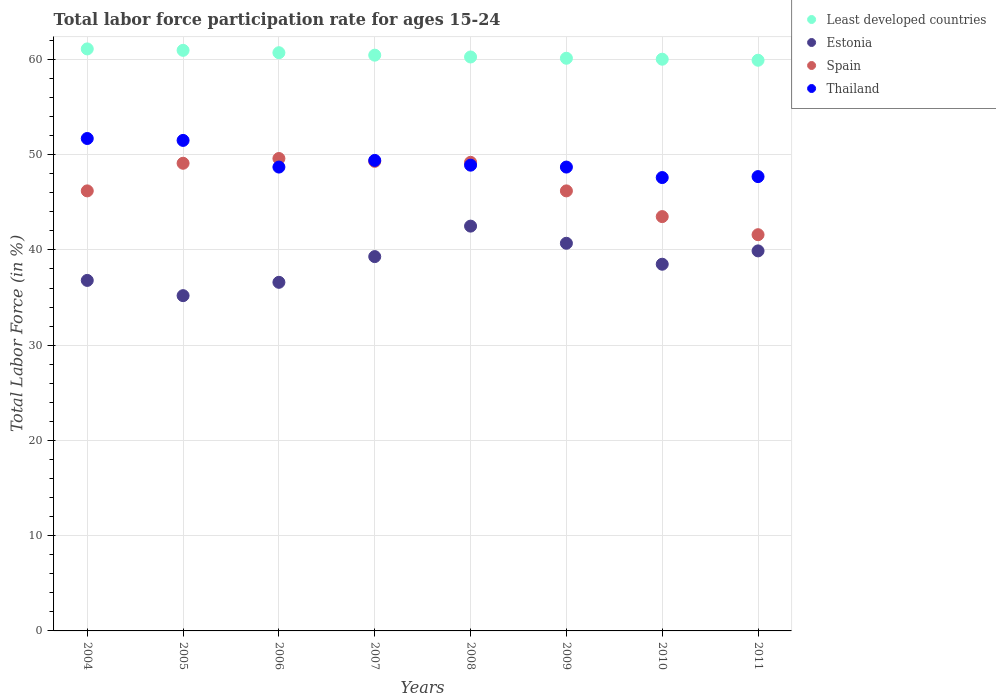Is the number of dotlines equal to the number of legend labels?
Ensure brevity in your answer.  Yes. What is the labor force participation rate in Estonia in 2004?
Provide a short and direct response. 36.8. Across all years, what is the maximum labor force participation rate in Thailand?
Provide a short and direct response. 51.7. Across all years, what is the minimum labor force participation rate in Least developed countries?
Provide a succinct answer. 59.92. What is the total labor force participation rate in Least developed countries in the graph?
Keep it short and to the point. 483.54. What is the difference between the labor force participation rate in Least developed countries in 2009 and that in 2011?
Your answer should be compact. 0.21. What is the difference between the labor force participation rate in Thailand in 2004 and the labor force participation rate in Estonia in 2010?
Keep it short and to the point. 13.2. What is the average labor force participation rate in Spain per year?
Provide a short and direct response. 46.84. In the year 2008, what is the difference between the labor force participation rate in Least developed countries and labor force participation rate in Spain?
Keep it short and to the point. 11.06. In how many years, is the labor force participation rate in Spain greater than 46 %?
Offer a very short reply. 6. What is the ratio of the labor force participation rate in Least developed countries in 2005 to that in 2009?
Give a very brief answer. 1.01. Is the labor force participation rate in Thailand in 2008 less than that in 2009?
Ensure brevity in your answer.  No. Is the difference between the labor force participation rate in Least developed countries in 2006 and 2007 greater than the difference between the labor force participation rate in Spain in 2006 and 2007?
Provide a succinct answer. No. What is the difference between the highest and the second highest labor force participation rate in Least developed countries?
Your response must be concise. 0.15. Is the sum of the labor force participation rate in Estonia in 2004 and 2006 greater than the maximum labor force participation rate in Spain across all years?
Your response must be concise. Yes. Is the labor force participation rate in Thailand strictly greater than the labor force participation rate in Estonia over the years?
Your answer should be very brief. Yes. How many years are there in the graph?
Your answer should be compact. 8. What is the difference between two consecutive major ticks on the Y-axis?
Keep it short and to the point. 10. Are the values on the major ticks of Y-axis written in scientific E-notation?
Your answer should be compact. No. Where does the legend appear in the graph?
Ensure brevity in your answer.  Top right. What is the title of the graph?
Provide a succinct answer. Total labor force participation rate for ages 15-24. What is the label or title of the Y-axis?
Your answer should be very brief. Total Labor Force (in %). What is the Total Labor Force (in %) in Least developed countries in 2004?
Your answer should be compact. 61.11. What is the Total Labor Force (in %) in Estonia in 2004?
Ensure brevity in your answer.  36.8. What is the Total Labor Force (in %) in Spain in 2004?
Keep it short and to the point. 46.2. What is the Total Labor Force (in %) of Thailand in 2004?
Your answer should be compact. 51.7. What is the Total Labor Force (in %) in Least developed countries in 2005?
Give a very brief answer. 60.96. What is the Total Labor Force (in %) in Estonia in 2005?
Provide a succinct answer. 35.2. What is the Total Labor Force (in %) of Spain in 2005?
Provide a succinct answer. 49.1. What is the Total Labor Force (in %) of Thailand in 2005?
Offer a very short reply. 51.5. What is the Total Labor Force (in %) in Least developed countries in 2006?
Your response must be concise. 60.71. What is the Total Labor Force (in %) in Estonia in 2006?
Provide a succinct answer. 36.6. What is the Total Labor Force (in %) of Spain in 2006?
Ensure brevity in your answer.  49.6. What is the Total Labor Force (in %) of Thailand in 2006?
Ensure brevity in your answer.  48.7. What is the Total Labor Force (in %) of Least developed countries in 2007?
Keep it short and to the point. 60.45. What is the Total Labor Force (in %) in Estonia in 2007?
Give a very brief answer. 39.3. What is the Total Labor Force (in %) in Spain in 2007?
Give a very brief answer. 49.3. What is the Total Labor Force (in %) of Thailand in 2007?
Give a very brief answer. 49.4. What is the Total Labor Force (in %) in Least developed countries in 2008?
Make the answer very short. 60.26. What is the Total Labor Force (in %) of Estonia in 2008?
Your response must be concise. 42.5. What is the Total Labor Force (in %) in Spain in 2008?
Keep it short and to the point. 49.2. What is the Total Labor Force (in %) of Thailand in 2008?
Your response must be concise. 48.9. What is the Total Labor Force (in %) in Least developed countries in 2009?
Ensure brevity in your answer.  60.13. What is the Total Labor Force (in %) of Estonia in 2009?
Give a very brief answer. 40.7. What is the Total Labor Force (in %) in Spain in 2009?
Provide a succinct answer. 46.2. What is the Total Labor Force (in %) in Thailand in 2009?
Your response must be concise. 48.7. What is the Total Labor Force (in %) in Least developed countries in 2010?
Offer a terse response. 60.02. What is the Total Labor Force (in %) in Estonia in 2010?
Offer a very short reply. 38.5. What is the Total Labor Force (in %) of Spain in 2010?
Provide a short and direct response. 43.5. What is the Total Labor Force (in %) in Thailand in 2010?
Ensure brevity in your answer.  47.6. What is the Total Labor Force (in %) of Least developed countries in 2011?
Provide a short and direct response. 59.92. What is the Total Labor Force (in %) in Estonia in 2011?
Make the answer very short. 39.9. What is the Total Labor Force (in %) of Spain in 2011?
Your answer should be very brief. 41.6. What is the Total Labor Force (in %) of Thailand in 2011?
Offer a terse response. 47.7. Across all years, what is the maximum Total Labor Force (in %) of Least developed countries?
Ensure brevity in your answer.  61.11. Across all years, what is the maximum Total Labor Force (in %) of Estonia?
Your response must be concise. 42.5. Across all years, what is the maximum Total Labor Force (in %) in Spain?
Make the answer very short. 49.6. Across all years, what is the maximum Total Labor Force (in %) of Thailand?
Offer a terse response. 51.7. Across all years, what is the minimum Total Labor Force (in %) of Least developed countries?
Ensure brevity in your answer.  59.92. Across all years, what is the minimum Total Labor Force (in %) in Estonia?
Provide a short and direct response. 35.2. Across all years, what is the minimum Total Labor Force (in %) of Spain?
Offer a terse response. 41.6. Across all years, what is the minimum Total Labor Force (in %) in Thailand?
Your response must be concise. 47.6. What is the total Total Labor Force (in %) of Least developed countries in the graph?
Your answer should be compact. 483.54. What is the total Total Labor Force (in %) in Estonia in the graph?
Your answer should be very brief. 309.5. What is the total Total Labor Force (in %) in Spain in the graph?
Provide a succinct answer. 374.7. What is the total Total Labor Force (in %) in Thailand in the graph?
Ensure brevity in your answer.  394.2. What is the difference between the Total Labor Force (in %) of Least developed countries in 2004 and that in 2005?
Provide a succinct answer. 0.15. What is the difference between the Total Labor Force (in %) of Least developed countries in 2004 and that in 2006?
Give a very brief answer. 0.4. What is the difference between the Total Labor Force (in %) in Least developed countries in 2004 and that in 2007?
Your answer should be very brief. 0.66. What is the difference between the Total Labor Force (in %) in Spain in 2004 and that in 2007?
Your answer should be very brief. -3.1. What is the difference between the Total Labor Force (in %) in Thailand in 2004 and that in 2007?
Offer a terse response. 2.3. What is the difference between the Total Labor Force (in %) of Least developed countries in 2004 and that in 2008?
Provide a short and direct response. 0.85. What is the difference between the Total Labor Force (in %) of Least developed countries in 2004 and that in 2009?
Your answer should be very brief. 0.98. What is the difference between the Total Labor Force (in %) in Estonia in 2004 and that in 2009?
Provide a succinct answer. -3.9. What is the difference between the Total Labor Force (in %) of Thailand in 2004 and that in 2009?
Offer a very short reply. 3. What is the difference between the Total Labor Force (in %) of Least developed countries in 2004 and that in 2010?
Offer a terse response. 1.08. What is the difference between the Total Labor Force (in %) in Estonia in 2004 and that in 2010?
Give a very brief answer. -1.7. What is the difference between the Total Labor Force (in %) of Spain in 2004 and that in 2010?
Offer a terse response. 2.7. What is the difference between the Total Labor Force (in %) in Thailand in 2004 and that in 2010?
Your answer should be compact. 4.1. What is the difference between the Total Labor Force (in %) of Least developed countries in 2004 and that in 2011?
Give a very brief answer. 1.19. What is the difference between the Total Labor Force (in %) of Estonia in 2004 and that in 2011?
Offer a terse response. -3.1. What is the difference between the Total Labor Force (in %) in Thailand in 2004 and that in 2011?
Provide a short and direct response. 4. What is the difference between the Total Labor Force (in %) in Least developed countries in 2005 and that in 2006?
Offer a terse response. 0.25. What is the difference between the Total Labor Force (in %) in Spain in 2005 and that in 2006?
Your response must be concise. -0.5. What is the difference between the Total Labor Force (in %) of Least developed countries in 2005 and that in 2007?
Offer a terse response. 0.51. What is the difference between the Total Labor Force (in %) in Estonia in 2005 and that in 2007?
Make the answer very short. -4.1. What is the difference between the Total Labor Force (in %) in Least developed countries in 2005 and that in 2008?
Your answer should be compact. 0.7. What is the difference between the Total Labor Force (in %) in Thailand in 2005 and that in 2008?
Make the answer very short. 2.6. What is the difference between the Total Labor Force (in %) of Least developed countries in 2005 and that in 2009?
Your answer should be very brief. 0.83. What is the difference between the Total Labor Force (in %) of Estonia in 2005 and that in 2009?
Provide a short and direct response. -5.5. What is the difference between the Total Labor Force (in %) in Spain in 2005 and that in 2009?
Your answer should be very brief. 2.9. What is the difference between the Total Labor Force (in %) of Least developed countries in 2005 and that in 2010?
Offer a very short reply. 0.93. What is the difference between the Total Labor Force (in %) in Spain in 2005 and that in 2010?
Provide a short and direct response. 5.6. What is the difference between the Total Labor Force (in %) in Least developed countries in 2005 and that in 2011?
Provide a short and direct response. 1.04. What is the difference between the Total Labor Force (in %) of Estonia in 2005 and that in 2011?
Offer a terse response. -4.7. What is the difference between the Total Labor Force (in %) of Spain in 2005 and that in 2011?
Keep it short and to the point. 7.5. What is the difference between the Total Labor Force (in %) in Thailand in 2005 and that in 2011?
Provide a short and direct response. 3.8. What is the difference between the Total Labor Force (in %) of Least developed countries in 2006 and that in 2007?
Provide a succinct answer. 0.26. What is the difference between the Total Labor Force (in %) of Spain in 2006 and that in 2007?
Offer a very short reply. 0.3. What is the difference between the Total Labor Force (in %) of Thailand in 2006 and that in 2007?
Your answer should be very brief. -0.7. What is the difference between the Total Labor Force (in %) of Least developed countries in 2006 and that in 2008?
Ensure brevity in your answer.  0.45. What is the difference between the Total Labor Force (in %) in Least developed countries in 2006 and that in 2009?
Your answer should be compact. 0.58. What is the difference between the Total Labor Force (in %) in Spain in 2006 and that in 2009?
Offer a very short reply. 3.4. What is the difference between the Total Labor Force (in %) in Least developed countries in 2006 and that in 2010?
Provide a succinct answer. 0.68. What is the difference between the Total Labor Force (in %) of Estonia in 2006 and that in 2010?
Ensure brevity in your answer.  -1.9. What is the difference between the Total Labor Force (in %) of Spain in 2006 and that in 2010?
Ensure brevity in your answer.  6.1. What is the difference between the Total Labor Force (in %) in Least developed countries in 2006 and that in 2011?
Provide a succinct answer. 0.79. What is the difference between the Total Labor Force (in %) in Estonia in 2006 and that in 2011?
Keep it short and to the point. -3.3. What is the difference between the Total Labor Force (in %) of Thailand in 2006 and that in 2011?
Provide a short and direct response. 1. What is the difference between the Total Labor Force (in %) of Least developed countries in 2007 and that in 2008?
Provide a short and direct response. 0.19. What is the difference between the Total Labor Force (in %) of Least developed countries in 2007 and that in 2009?
Make the answer very short. 0.32. What is the difference between the Total Labor Force (in %) of Estonia in 2007 and that in 2009?
Offer a very short reply. -1.4. What is the difference between the Total Labor Force (in %) of Spain in 2007 and that in 2009?
Provide a succinct answer. 3.1. What is the difference between the Total Labor Force (in %) of Thailand in 2007 and that in 2009?
Provide a short and direct response. 0.7. What is the difference between the Total Labor Force (in %) in Least developed countries in 2007 and that in 2010?
Keep it short and to the point. 0.42. What is the difference between the Total Labor Force (in %) of Estonia in 2007 and that in 2010?
Give a very brief answer. 0.8. What is the difference between the Total Labor Force (in %) of Spain in 2007 and that in 2010?
Make the answer very short. 5.8. What is the difference between the Total Labor Force (in %) in Thailand in 2007 and that in 2010?
Keep it short and to the point. 1.8. What is the difference between the Total Labor Force (in %) in Least developed countries in 2007 and that in 2011?
Keep it short and to the point. 0.53. What is the difference between the Total Labor Force (in %) of Spain in 2007 and that in 2011?
Keep it short and to the point. 7.7. What is the difference between the Total Labor Force (in %) of Least developed countries in 2008 and that in 2009?
Offer a very short reply. 0.13. What is the difference between the Total Labor Force (in %) in Least developed countries in 2008 and that in 2010?
Your answer should be compact. 0.23. What is the difference between the Total Labor Force (in %) in Thailand in 2008 and that in 2010?
Offer a very short reply. 1.3. What is the difference between the Total Labor Force (in %) of Least developed countries in 2008 and that in 2011?
Provide a succinct answer. 0.34. What is the difference between the Total Labor Force (in %) of Estonia in 2008 and that in 2011?
Give a very brief answer. 2.6. What is the difference between the Total Labor Force (in %) of Spain in 2008 and that in 2011?
Make the answer very short. 7.6. What is the difference between the Total Labor Force (in %) in Thailand in 2008 and that in 2011?
Give a very brief answer. 1.2. What is the difference between the Total Labor Force (in %) in Least developed countries in 2009 and that in 2010?
Offer a terse response. 0.1. What is the difference between the Total Labor Force (in %) in Estonia in 2009 and that in 2010?
Your response must be concise. 2.2. What is the difference between the Total Labor Force (in %) of Thailand in 2009 and that in 2010?
Provide a short and direct response. 1.1. What is the difference between the Total Labor Force (in %) in Least developed countries in 2009 and that in 2011?
Offer a very short reply. 0.21. What is the difference between the Total Labor Force (in %) in Estonia in 2009 and that in 2011?
Offer a terse response. 0.8. What is the difference between the Total Labor Force (in %) of Least developed countries in 2010 and that in 2011?
Your response must be concise. 0.11. What is the difference between the Total Labor Force (in %) of Estonia in 2010 and that in 2011?
Offer a very short reply. -1.4. What is the difference between the Total Labor Force (in %) in Thailand in 2010 and that in 2011?
Make the answer very short. -0.1. What is the difference between the Total Labor Force (in %) in Least developed countries in 2004 and the Total Labor Force (in %) in Estonia in 2005?
Keep it short and to the point. 25.91. What is the difference between the Total Labor Force (in %) of Least developed countries in 2004 and the Total Labor Force (in %) of Spain in 2005?
Keep it short and to the point. 12.01. What is the difference between the Total Labor Force (in %) in Least developed countries in 2004 and the Total Labor Force (in %) in Thailand in 2005?
Provide a succinct answer. 9.61. What is the difference between the Total Labor Force (in %) of Estonia in 2004 and the Total Labor Force (in %) of Thailand in 2005?
Ensure brevity in your answer.  -14.7. What is the difference between the Total Labor Force (in %) in Spain in 2004 and the Total Labor Force (in %) in Thailand in 2005?
Keep it short and to the point. -5.3. What is the difference between the Total Labor Force (in %) in Least developed countries in 2004 and the Total Labor Force (in %) in Estonia in 2006?
Offer a very short reply. 24.51. What is the difference between the Total Labor Force (in %) in Least developed countries in 2004 and the Total Labor Force (in %) in Spain in 2006?
Provide a short and direct response. 11.51. What is the difference between the Total Labor Force (in %) in Least developed countries in 2004 and the Total Labor Force (in %) in Thailand in 2006?
Ensure brevity in your answer.  12.41. What is the difference between the Total Labor Force (in %) of Estonia in 2004 and the Total Labor Force (in %) of Spain in 2006?
Give a very brief answer. -12.8. What is the difference between the Total Labor Force (in %) in Estonia in 2004 and the Total Labor Force (in %) in Thailand in 2006?
Offer a very short reply. -11.9. What is the difference between the Total Labor Force (in %) of Spain in 2004 and the Total Labor Force (in %) of Thailand in 2006?
Your answer should be very brief. -2.5. What is the difference between the Total Labor Force (in %) of Least developed countries in 2004 and the Total Labor Force (in %) of Estonia in 2007?
Your response must be concise. 21.81. What is the difference between the Total Labor Force (in %) in Least developed countries in 2004 and the Total Labor Force (in %) in Spain in 2007?
Give a very brief answer. 11.81. What is the difference between the Total Labor Force (in %) of Least developed countries in 2004 and the Total Labor Force (in %) of Thailand in 2007?
Provide a succinct answer. 11.71. What is the difference between the Total Labor Force (in %) in Estonia in 2004 and the Total Labor Force (in %) in Spain in 2007?
Give a very brief answer. -12.5. What is the difference between the Total Labor Force (in %) in Spain in 2004 and the Total Labor Force (in %) in Thailand in 2007?
Keep it short and to the point. -3.2. What is the difference between the Total Labor Force (in %) of Least developed countries in 2004 and the Total Labor Force (in %) of Estonia in 2008?
Offer a terse response. 18.61. What is the difference between the Total Labor Force (in %) of Least developed countries in 2004 and the Total Labor Force (in %) of Spain in 2008?
Offer a terse response. 11.91. What is the difference between the Total Labor Force (in %) of Least developed countries in 2004 and the Total Labor Force (in %) of Thailand in 2008?
Your answer should be compact. 12.21. What is the difference between the Total Labor Force (in %) of Estonia in 2004 and the Total Labor Force (in %) of Thailand in 2008?
Offer a very short reply. -12.1. What is the difference between the Total Labor Force (in %) of Spain in 2004 and the Total Labor Force (in %) of Thailand in 2008?
Give a very brief answer. -2.7. What is the difference between the Total Labor Force (in %) in Least developed countries in 2004 and the Total Labor Force (in %) in Estonia in 2009?
Your answer should be compact. 20.41. What is the difference between the Total Labor Force (in %) in Least developed countries in 2004 and the Total Labor Force (in %) in Spain in 2009?
Your answer should be very brief. 14.91. What is the difference between the Total Labor Force (in %) of Least developed countries in 2004 and the Total Labor Force (in %) of Thailand in 2009?
Provide a succinct answer. 12.41. What is the difference between the Total Labor Force (in %) in Estonia in 2004 and the Total Labor Force (in %) in Thailand in 2009?
Make the answer very short. -11.9. What is the difference between the Total Labor Force (in %) in Spain in 2004 and the Total Labor Force (in %) in Thailand in 2009?
Provide a short and direct response. -2.5. What is the difference between the Total Labor Force (in %) in Least developed countries in 2004 and the Total Labor Force (in %) in Estonia in 2010?
Make the answer very short. 22.61. What is the difference between the Total Labor Force (in %) of Least developed countries in 2004 and the Total Labor Force (in %) of Spain in 2010?
Offer a terse response. 17.61. What is the difference between the Total Labor Force (in %) in Least developed countries in 2004 and the Total Labor Force (in %) in Thailand in 2010?
Make the answer very short. 13.51. What is the difference between the Total Labor Force (in %) in Estonia in 2004 and the Total Labor Force (in %) in Thailand in 2010?
Keep it short and to the point. -10.8. What is the difference between the Total Labor Force (in %) in Least developed countries in 2004 and the Total Labor Force (in %) in Estonia in 2011?
Provide a succinct answer. 21.21. What is the difference between the Total Labor Force (in %) of Least developed countries in 2004 and the Total Labor Force (in %) of Spain in 2011?
Offer a very short reply. 19.51. What is the difference between the Total Labor Force (in %) in Least developed countries in 2004 and the Total Labor Force (in %) in Thailand in 2011?
Make the answer very short. 13.41. What is the difference between the Total Labor Force (in %) in Estonia in 2004 and the Total Labor Force (in %) in Spain in 2011?
Ensure brevity in your answer.  -4.8. What is the difference between the Total Labor Force (in %) of Estonia in 2004 and the Total Labor Force (in %) of Thailand in 2011?
Provide a short and direct response. -10.9. What is the difference between the Total Labor Force (in %) in Least developed countries in 2005 and the Total Labor Force (in %) in Estonia in 2006?
Ensure brevity in your answer.  24.36. What is the difference between the Total Labor Force (in %) of Least developed countries in 2005 and the Total Labor Force (in %) of Spain in 2006?
Your answer should be very brief. 11.36. What is the difference between the Total Labor Force (in %) of Least developed countries in 2005 and the Total Labor Force (in %) of Thailand in 2006?
Offer a very short reply. 12.26. What is the difference between the Total Labor Force (in %) in Estonia in 2005 and the Total Labor Force (in %) in Spain in 2006?
Keep it short and to the point. -14.4. What is the difference between the Total Labor Force (in %) of Estonia in 2005 and the Total Labor Force (in %) of Thailand in 2006?
Your answer should be compact. -13.5. What is the difference between the Total Labor Force (in %) in Spain in 2005 and the Total Labor Force (in %) in Thailand in 2006?
Make the answer very short. 0.4. What is the difference between the Total Labor Force (in %) of Least developed countries in 2005 and the Total Labor Force (in %) of Estonia in 2007?
Your response must be concise. 21.66. What is the difference between the Total Labor Force (in %) in Least developed countries in 2005 and the Total Labor Force (in %) in Spain in 2007?
Keep it short and to the point. 11.66. What is the difference between the Total Labor Force (in %) in Least developed countries in 2005 and the Total Labor Force (in %) in Thailand in 2007?
Make the answer very short. 11.56. What is the difference between the Total Labor Force (in %) of Estonia in 2005 and the Total Labor Force (in %) of Spain in 2007?
Keep it short and to the point. -14.1. What is the difference between the Total Labor Force (in %) of Spain in 2005 and the Total Labor Force (in %) of Thailand in 2007?
Provide a short and direct response. -0.3. What is the difference between the Total Labor Force (in %) in Least developed countries in 2005 and the Total Labor Force (in %) in Estonia in 2008?
Your answer should be very brief. 18.46. What is the difference between the Total Labor Force (in %) in Least developed countries in 2005 and the Total Labor Force (in %) in Spain in 2008?
Your response must be concise. 11.76. What is the difference between the Total Labor Force (in %) of Least developed countries in 2005 and the Total Labor Force (in %) of Thailand in 2008?
Your response must be concise. 12.06. What is the difference between the Total Labor Force (in %) in Estonia in 2005 and the Total Labor Force (in %) in Thailand in 2008?
Make the answer very short. -13.7. What is the difference between the Total Labor Force (in %) in Spain in 2005 and the Total Labor Force (in %) in Thailand in 2008?
Your answer should be compact. 0.2. What is the difference between the Total Labor Force (in %) of Least developed countries in 2005 and the Total Labor Force (in %) of Estonia in 2009?
Offer a terse response. 20.26. What is the difference between the Total Labor Force (in %) of Least developed countries in 2005 and the Total Labor Force (in %) of Spain in 2009?
Provide a succinct answer. 14.76. What is the difference between the Total Labor Force (in %) in Least developed countries in 2005 and the Total Labor Force (in %) in Thailand in 2009?
Give a very brief answer. 12.26. What is the difference between the Total Labor Force (in %) of Estonia in 2005 and the Total Labor Force (in %) of Thailand in 2009?
Your response must be concise. -13.5. What is the difference between the Total Labor Force (in %) in Least developed countries in 2005 and the Total Labor Force (in %) in Estonia in 2010?
Offer a very short reply. 22.46. What is the difference between the Total Labor Force (in %) in Least developed countries in 2005 and the Total Labor Force (in %) in Spain in 2010?
Provide a succinct answer. 17.46. What is the difference between the Total Labor Force (in %) in Least developed countries in 2005 and the Total Labor Force (in %) in Thailand in 2010?
Make the answer very short. 13.36. What is the difference between the Total Labor Force (in %) of Estonia in 2005 and the Total Labor Force (in %) of Spain in 2010?
Keep it short and to the point. -8.3. What is the difference between the Total Labor Force (in %) in Estonia in 2005 and the Total Labor Force (in %) in Thailand in 2010?
Ensure brevity in your answer.  -12.4. What is the difference between the Total Labor Force (in %) in Least developed countries in 2005 and the Total Labor Force (in %) in Estonia in 2011?
Offer a very short reply. 21.06. What is the difference between the Total Labor Force (in %) of Least developed countries in 2005 and the Total Labor Force (in %) of Spain in 2011?
Your answer should be very brief. 19.36. What is the difference between the Total Labor Force (in %) of Least developed countries in 2005 and the Total Labor Force (in %) of Thailand in 2011?
Your response must be concise. 13.26. What is the difference between the Total Labor Force (in %) in Estonia in 2005 and the Total Labor Force (in %) in Spain in 2011?
Your response must be concise. -6.4. What is the difference between the Total Labor Force (in %) of Estonia in 2005 and the Total Labor Force (in %) of Thailand in 2011?
Give a very brief answer. -12.5. What is the difference between the Total Labor Force (in %) in Least developed countries in 2006 and the Total Labor Force (in %) in Estonia in 2007?
Give a very brief answer. 21.41. What is the difference between the Total Labor Force (in %) in Least developed countries in 2006 and the Total Labor Force (in %) in Spain in 2007?
Your answer should be compact. 11.41. What is the difference between the Total Labor Force (in %) in Least developed countries in 2006 and the Total Labor Force (in %) in Thailand in 2007?
Provide a succinct answer. 11.31. What is the difference between the Total Labor Force (in %) of Estonia in 2006 and the Total Labor Force (in %) of Thailand in 2007?
Offer a very short reply. -12.8. What is the difference between the Total Labor Force (in %) in Spain in 2006 and the Total Labor Force (in %) in Thailand in 2007?
Offer a very short reply. 0.2. What is the difference between the Total Labor Force (in %) of Least developed countries in 2006 and the Total Labor Force (in %) of Estonia in 2008?
Your answer should be very brief. 18.21. What is the difference between the Total Labor Force (in %) in Least developed countries in 2006 and the Total Labor Force (in %) in Spain in 2008?
Provide a short and direct response. 11.51. What is the difference between the Total Labor Force (in %) of Least developed countries in 2006 and the Total Labor Force (in %) of Thailand in 2008?
Your answer should be very brief. 11.81. What is the difference between the Total Labor Force (in %) in Estonia in 2006 and the Total Labor Force (in %) in Spain in 2008?
Provide a succinct answer. -12.6. What is the difference between the Total Labor Force (in %) in Estonia in 2006 and the Total Labor Force (in %) in Thailand in 2008?
Provide a short and direct response. -12.3. What is the difference between the Total Labor Force (in %) of Spain in 2006 and the Total Labor Force (in %) of Thailand in 2008?
Your response must be concise. 0.7. What is the difference between the Total Labor Force (in %) of Least developed countries in 2006 and the Total Labor Force (in %) of Estonia in 2009?
Your response must be concise. 20.01. What is the difference between the Total Labor Force (in %) of Least developed countries in 2006 and the Total Labor Force (in %) of Spain in 2009?
Your answer should be very brief. 14.51. What is the difference between the Total Labor Force (in %) of Least developed countries in 2006 and the Total Labor Force (in %) of Thailand in 2009?
Make the answer very short. 12.01. What is the difference between the Total Labor Force (in %) in Least developed countries in 2006 and the Total Labor Force (in %) in Estonia in 2010?
Give a very brief answer. 22.21. What is the difference between the Total Labor Force (in %) of Least developed countries in 2006 and the Total Labor Force (in %) of Spain in 2010?
Provide a succinct answer. 17.21. What is the difference between the Total Labor Force (in %) in Least developed countries in 2006 and the Total Labor Force (in %) in Thailand in 2010?
Provide a succinct answer. 13.11. What is the difference between the Total Labor Force (in %) of Estonia in 2006 and the Total Labor Force (in %) of Thailand in 2010?
Give a very brief answer. -11. What is the difference between the Total Labor Force (in %) of Least developed countries in 2006 and the Total Labor Force (in %) of Estonia in 2011?
Keep it short and to the point. 20.81. What is the difference between the Total Labor Force (in %) in Least developed countries in 2006 and the Total Labor Force (in %) in Spain in 2011?
Make the answer very short. 19.11. What is the difference between the Total Labor Force (in %) of Least developed countries in 2006 and the Total Labor Force (in %) of Thailand in 2011?
Give a very brief answer. 13.01. What is the difference between the Total Labor Force (in %) in Estonia in 2006 and the Total Labor Force (in %) in Thailand in 2011?
Offer a terse response. -11.1. What is the difference between the Total Labor Force (in %) in Spain in 2006 and the Total Labor Force (in %) in Thailand in 2011?
Provide a short and direct response. 1.9. What is the difference between the Total Labor Force (in %) of Least developed countries in 2007 and the Total Labor Force (in %) of Estonia in 2008?
Provide a succinct answer. 17.95. What is the difference between the Total Labor Force (in %) in Least developed countries in 2007 and the Total Labor Force (in %) in Spain in 2008?
Provide a short and direct response. 11.25. What is the difference between the Total Labor Force (in %) of Least developed countries in 2007 and the Total Labor Force (in %) of Thailand in 2008?
Your answer should be compact. 11.55. What is the difference between the Total Labor Force (in %) of Least developed countries in 2007 and the Total Labor Force (in %) of Estonia in 2009?
Offer a very short reply. 19.75. What is the difference between the Total Labor Force (in %) of Least developed countries in 2007 and the Total Labor Force (in %) of Spain in 2009?
Keep it short and to the point. 14.25. What is the difference between the Total Labor Force (in %) in Least developed countries in 2007 and the Total Labor Force (in %) in Thailand in 2009?
Offer a very short reply. 11.75. What is the difference between the Total Labor Force (in %) in Estonia in 2007 and the Total Labor Force (in %) in Thailand in 2009?
Keep it short and to the point. -9.4. What is the difference between the Total Labor Force (in %) of Least developed countries in 2007 and the Total Labor Force (in %) of Estonia in 2010?
Your response must be concise. 21.95. What is the difference between the Total Labor Force (in %) of Least developed countries in 2007 and the Total Labor Force (in %) of Spain in 2010?
Ensure brevity in your answer.  16.95. What is the difference between the Total Labor Force (in %) in Least developed countries in 2007 and the Total Labor Force (in %) in Thailand in 2010?
Offer a very short reply. 12.85. What is the difference between the Total Labor Force (in %) of Estonia in 2007 and the Total Labor Force (in %) of Thailand in 2010?
Keep it short and to the point. -8.3. What is the difference between the Total Labor Force (in %) in Least developed countries in 2007 and the Total Labor Force (in %) in Estonia in 2011?
Provide a short and direct response. 20.55. What is the difference between the Total Labor Force (in %) in Least developed countries in 2007 and the Total Labor Force (in %) in Spain in 2011?
Offer a very short reply. 18.85. What is the difference between the Total Labor Force (in %) of Least developed countries in 2007 and the Total Labor Force (in %) of Thailand in 2011?
Your answer should be compact. 12.75. What is the difference between the Total Labor Force (in %) in Estonia in 2007 and the Total Labor Force (in %) in Thailand in 2011?
Your answer should be compact. -8.4. What is the difference between the Total Labor Force (in %) of Least developed countries in 2008 and the Total Labor Force (in %) of Estonia in 2009?
Give a very brief answer. 19.56. What is the difference between the Total Labor Force (in %) in Least developed countries in 2008 and the Total Labor Force (in %) in Spain in 2009?
Your response must be concise. 14.06. What is the difference between the Total Labor Force (in %) of Least developed countries in 2008 and the Total Labor Force (in %) of Thailand in 2009?
Your response must be concise. 11.56. What is the difference between the Total Labor Force (in %) of Estonia in 2008 and the Total Labor Force (in %) of Thailand in 2009?
Keep it short and to the point. -6.2. What is the difference between the Total Labor Force (in %) of Spain in 2008 and the Total Labor Force (in %) of Thailand in 2009?
Ensure brevity in your answer.  0.5. What is the difference between the Total Labor Force (in %) of Least developed countries in 2008 and the Total Labor Force (in %) of Estonia in 2010?
Your answer should be very brief. 21.76. What is the difference between the Total Labor Force (in %) of Least developed countries in 2008 and the Total Labor Force (in %) of Spain in 2010?
Provide a succinct answer. 16.76. What is the difference between the Total Labor Force (in %) of Least developed countries in 2008 and the Total Labor Force (in %) of Thailand in 2010?
Your answer should be very brief. 12.66. What is the difference between the Total Labor Force (in %) of Estonia in 2008 and the Total Labor Force (in %) of Spain in 2010?
Ensure brevity in your answer.  -1. What is the difference between the Total Labor Force (in %) of Spain in 2008 and the Total Labor Force (in %) of Thailand in 2010?
Provide a short and direct response. 1.6. What is the difference between the Total Labor Force (in %) in Least developed countries in 2008 and the Total Labor Force (in %) in Estonia in 2011?
Ensure brevity in your answer.  20.36. What is the difference between the Total Labor Force (in %) in Least developed countries in 2008 and the Total Labor Force (in %) in Spain in 2011?
Provide a succinct answer. 18.66. What is the difference between the Total Labor Force (in %) of Least developed countries in 2008 and the Total Labor Force (in %) of Thailand in 2011?
Make the answer very short. 12.56. What is the difference between the Total Labor Force (in %) in Estonia in 2008 and the Total Labor Force (in %) in Thailand in 2011?
Offer a terse response. -5.2. What is the difference between the Total Labor Force (in %) in Spain in 2008 and the Total Labor Force (in %) in Thailand in 2011?
Give a very brief answer. 1.5. What is the difference between the Total Labor Force (in %) of Least developed countries in 2009 and the Total Labor Force (in %) of Estonia in 2010?
Keep it short and to the point. 21.63. What is the difference between the Total Labor Force (in %) in Least developed countries in 2009 and the Total Labor Force (in %) in Spain in 2010?
Ensure brevity in your answer.  16.63. What is the difference between the Total Labor Force (in %) in Least developed countries in 2009 and the Total Labor Force (in %) in Thailand in 2010?
Provide a succinct answer. 12.53. What is the difference between the Total Labor Force (in %) of Spain in 2009 and the Total Labor Force (in %) of Thailand in 2010?
Your response must be concise. -1.4. What is the difference between the Total Labor Force (in %) in Least developed countries in 2009 and the Total Labor Force (in %) in Estonia in 2011?
Keep it short and to the point. 20.23. What is the difference between the Total Labor Force (in %) in Least developed countries in 2009 and the Total Labor Force (in %) in Spain in 2011?
Provide a succinct answer. 18.53. What is the difference between the Total Labor Force (in %) of Least developed countries in 2009 and the Total Labor Force (in %) of Thailand in 2011?
Your answer should be compact. 12.43. What is the difference between the Total Labor Force (in %) in Least developed countries in 2010 and the Total Labor Force (in %) in Estonia in 2011?
Offer a very short reply. 20.12. What is the difference between the Total Labor Force (in %) of Least developed countries in 2010 and the Total Labor Force (in %) of Spain in 2011?
Your answer should be very brief. 18.42. What is the difference between the Total Labor Force (in %) in Least developed countries in 2010 and the Total Labor Force (in %) in Thailand in 2011?
Your answer should be very brief. 12.32. What is the difference between the Total Labor Force (in %) of Estonia in 2010 and the Total Labor Force (in %) of Thailand in 2011?
Provide a succinct answer. -9.2. What is the difference between the Total Labor Force (in %) of Spain in 2010 and the Total Labor Force (in %) of Thailand in 2011?
Your response must be concise. -4.2. What is the average Total Labor Force (in %) of Least developed countries per year?
Offer a very short reply. 60.44. What is the average Total Labor Force (in %) in Estonia per year?
Offer a very short reply. 38.69. What is the average Total Labor Force (in %) in Spain per year?
Keep it short and to the point. 46.84. What is the average Total Labor Force (in %) of Thailand per year?
Provide a short and direct response. 49.27. In the year 2004, what is the difference between the Total Labor Force (in %) in Least developed countries and Total Labor Force (in %) in Estonia?
Your answer should be very brief. 24.31. In the year 2004, what is the difference between the Total Labor Force (in %) in Least developed countries and Total Labor Force (in %) in Spain?
Offer a very short reply. 14.91. In the year 2004, what is the difference between the Total Labor Force (in %) of Least developed countries and Total Labor Force (in %) of Thailand?
Keep it short and to the point. 9.41. In the year 2004, what is the difference between the Total Labor Force (in %) of Estonia and Total Labor Force (in %) of Spain?
Your response must be concise. -9.4. In the year 2004, what is the difference between the Total Labor Force (in %) in Estonia and Total Labor Force (in %) in Thailand?
Your answer should be very brief. -14.9. In the year 2004, what is the difference between the Total Labor Force (in %) in Spain and Total Labor Force (in %) in Thailand?
Provide a succinct answer. -5.5. In the year 2005, what is the difference between the Total Labor Force (in %) of Least developed countries and Total Labor Force (in %) of Estonia?
Provide a short and direct response. 25.76. In the year 2005, what is the difference between the Total Labor Force (in %) in Least developed countries and Total Labor Force (in %) in Spain?
Give a very brief answer. 11.86. In the year 2005, what is the difference between the Total Labor Force (in %) of Least developed countries and Total Labor Force (in %) of Thailand?
Provide a short and direct response. 9.46. In the year 2005, what is the difference between the Total Labor Force (in %) in Estonia and Total Labor Force (in %) in Spain?
Ensure brevity in your answer.  -13.9. In the year 2005, what is the difference between the Total Labor Force (in %) of Estonia and Total Labor Force (in %) of Thailand?
Keep it short and to the point. -16.3. In the year 2005, what is the difference between the Total Labor Force (in %) in Spain and Total Labor Force (in %) in Thailand?
Make the answer very short. -2.4. In the year 2006, what is the difference between the Total Labor Force (in %) of Least developed countries and Total Labor Force (in %) of Estonia?
Make the answer very short. 24.11. In the year 2006, what is the difference between the Total Labor Force (in %) of Least developed countries and Total Labor Force (in %) of Spain?
Keep it short and to the point. 11.11. In the year 2006, what is the difference between the Total Labor Force (in %) in Least developed countries and Total Labor Force (in %) in Thailand?
Keep it short and to the point. 12.01. In the year 2006, what is the difference between the Total Labor Force (in %) of Estonia and Total Labor Force (in %) of Spain?
Your response must be concise. -13. In the year 2007, what is the difference between the Total Labor Force (in %) of Least developed countries and Total Labor Force (in %) of Estonia?
Provide a succinct answer. 21.15. In the year 2007, what is the difference between the Total Labor Force (in %) in Least developed countries and Total Labor Force (in %) in Spain?
Give a very brief answer. 11.15. In the year 2007, what is the difference between the Total Labor Force (in %) in Least developed countries and Total Labor Force (in %) in Thailand?
Your answer should be compact. 11.05. In the year 2007, what is the difference between the Total Labor Force (in %) of Spain and Total Labor Force (in %) of Thailand?
Give a very brief answer. -0.1. In the year 2008, what is the difference between the Total Labor Force (in %) in Least developed countries and Total Labor Force (in %) in Estonia?
Your answer should be compact. 17.76. In the year 2008, what is the difference between the Total Labor Force (in %) in Least developed countries and Total Labor Force (in %) in Spain?
Ensure brevity in your answer.  11.06. In the year 2008, what is the difference between the Total Labor Force (in %) of Least developed countries and Total Labor Force (in %) of Thailand?
Keep it short and to the point. 11.36. In the year 2008, what is the difference between the Total Labor Force (in %) of Spain and Total Labor Force (in %) of Thailand?
Your answer should be compact. 0.3. In the year 2009, what is the difference between the Total Labor Force (in %) in Least developed countries and Total Labor Force (in %) in Estonia?
Give a very brief answer. 19.43. In the year 2009, what is the difference between the Total Labor Force (in %) of Least developed countries and Total Labor Force (in %) of Spain?
Offer a terse response. 13.93. In the year 2009, what is the difference between the Total Labor Force (in %) of Least developed countries and Total Labor Force (in %) of Thailand?
Offer a terse response. 11.43. In the year 2009, what is the difference between the Total Labor Force (in %) of Estonia and Total Labor Force (in %) of Thailand?
Offer a terse response. -8. In the year 2010, what is the difference between the Total Labor Force (in %) of Least developed countries and Total Labor Force (in %) of Estonia?
Your response must be concise. 21.52. In the year 2010, what is the difference between the Total Labor Force (in %) of Least developed countries and Total Labor Force (in %) of Spain?
Provide a succinct answer. 16.52. In the year 2010, what is the difference between the Total Labor Force (in %) in Least developed countries and Total Labor Force (in %) in Thailand?
Provide a short and direct response. 12.42. In the year 2010, what is the difference between the Total Labor Force (in %) in Estonia and Total Labor Force (in %) in Spain?
Your response must be concise. -5. In the year 2010, what is the difference between the Total Labor Force (in %) of Spain and Total Labor Force (in %) of Thailand?
Give a very brief answer. -4.1. In the year 2011, what is the difference between the Total Labor Force (in %) of Least developed countries and Total Labor Force (in %) of Estonia?
Give a very brief answer. 20.02. In the year 2011, what is the difference between the Total Labor Force (in %) in Least developed countries and Total Labor Force (in %) in Spain?
Your response must be concise. 18.32. In the year 2011, what is the difference between the Total Labor Force (in %) of Least developed countries and Total Labor Force (in %) of Thailand?
Your response must be concise. 12.22. In the year 2011, what is the difference between the Total Labor Force (in %) in Estonia and Total Labor Force (in %) in Spain?
Provide a short and direct response. -1.7. In the year 2011, what is the difference between the Total Labor Force (in %) of Estonia and Total Labor Force (in %) of Thailand?
Offer a very short reply. -7.8. In the year 2011, what is the difference between the Total Labor Force (in %) of Spain and Total Labor Force (in %) of Thailand?
Your response must be concise. -6.1. What is the ratio of the Total Labor Force (in %) of Estonia in 2004 to that in 2005?
Your answer should be very brief. 1.05. What is the ratio of the Total Labor Force (in %) in Spain in 2004 to that in 2005?
Keep it short and to the point. 0.94. What is the ratio of the Total Labor Force (in %) in Thailand in 2004 to that in 2005?
Your response must be concise. 1. What is the ratio of the Total Labor Force (in %) in Least developed countries in 2004 to that in 2006?
Make the answer very short. 1.01. What is the ratio of the Total Labor Force (in %) in Estonia in 2004 to that in 2006?
Give a very brief answer. 1.01. What is the ratio of the Total Labor Force (in %) in Spain in 2004 to that in 2006?
Give a very brief answer. 0.93. What is the ratio of the Total Labor Force (in %) of Thailand in 2004 to that in 2006?
Provide a short and direct response. 1.06. What is the ratio of the Total Labor Force (in %) of Least developed countries in 2004 to that in 2007?
Provide a succinct answer. 1.01. What is the ratio of the Total Labor Force (in %) in Estonia in 2004 to that in 2007?
Keep it short and to the point. 0.94. What is the ratio of the Total Labor Force (in %) in Spain in 2004 to that in 2007?
Offer a terse response. 0.94. What is the ratio of the Total Labor Force (in %) of Thailand in 2004 to that in 2007?
Offer a terse response. 1.05. What is the ratio of the Total Labor Force (in %) of Estonia in 2004 to that in 2008?
Provide a succinct answer. 0.87. What is the ratio of the Total Labor Force (in %) in Spain in 2004 to that in 2008?
Your answer should be very brief. 0.94. What is the ratio of the Total Labor Force (in %) in Thailand in 2004 to that in 2008?
Offer a very short reply. 1.06. What is the ratio of the Total Labor Force (in %) in Least developed countries in 2004 to that in 2009?
Give a very brief answer. 1.02. What is the ratio of the Total Labor Force (in %) of Estonia in 2004 to that in 2009?
Ensure brevity in your answer.  0.9. What is the ratio of the Total Labor Force (in %) in Spain in 2004 to that in 2009?
Provide a short and direct response. 1. What is the ratio of the Total Labor Force (in %) in Thailand in 2004 to that in 2009?
Your response must be concise. 1.06. What is the ratio of the Total Labor Force (in %) of Estonia in 2004 to that in 2010?
Make the answer very short. 0.96. What is the ratio of the Total Labor Force (in %) in Spain in 2004 to that in 2010?
Make the answer very short. 1.06. What is the ratio of the Total Labor Force (in %) in Thailand in 2004 to that in 2010?
Provide a short and direct response. 1.09. What is the ratio of the Total Labor Force (in %) of Least developed countries in 2004 to that in 2011?
Provide a short and direct response. 1.02. What is the ratio of the Total Labor Force (in %) in Estonia in 2004 to that in 2011?
Offer a very short reply. 0.92. What is the ratio of the Total Labor Force (in %) in Spain in 2004 to that in 2011?
Provide a short and direct response. 1.11. What is the ratio of the Total Labor Force (in %) of Thailand in 2004 to that in 2011?
Offer a terse response. 1.08. What is the ratio of the Total Labor Force (in %) of Estonia in 2005 to that in 2006?
Your answer should be very brief. 0.96. What is the ratio of the Total Labor Force (in %) in Spain in 2005 to that in 2006?
Make the answer very short. 0.99. What is the ratio of the Total Labor Force (in %) of Thailand in 2005 to that in 2006?
Offer a very short reply. 1.06. What is the ratio of the Total Labor Force (in %) of Least developed countries in 2005 to that in 2007?
Keep it short and to the point. 1.01. What is the ratio of the Total Labor Force (in %) in Estonia in 2005 to that in 2007?
Make the answer very short. 0.9. What is the ratio of the Total Labor Force (in %) in Thailand in 2005 to that in 2007?
Give a very brief answer. 1.04. What is the ratio of the Total Labor Force (in %) of Least developed countries in 2005 to that in 2008?
Your response must be concise. 1.01. What is the ratio of the Total Labor Force (in %) in Estonia in 2005 to that in 2008?
Make the answer very short. 0.83. What is the ratio of the Total Labor Force (in %) of Thailand in 2005 to that in 2008?
Keep it short and to the point. 1.05. What is the ratio of the Total Labor Force (in %) in Least developed countries in 2005 to that in 2009?
Provide a succinct answer. 1.01. What is the ratio of the Total Labor Force (in %) of Estonia in 2005 to that in 2009?
Make the answer very short. 0.86. What is the ratio of the Total Labor Force (in %) in Spain in 2005 to that in 2009?
Your answer should be very brief. 1.06. What is the ratio of the Total Labor Force (in %) of Thailand in 2005 to that in 2009?
Provide a succinct answer. 1.06. What is the ratio of the Total Labor Force (in %) in Least developed countries in 2005 to that in 2010?
Offer a very short reply. 1.02. What is the ratio of the Total Labor Force (in %) in Estonia in 2005 to that in 2010?
Provide a short and direct response. 0.91. What is the ratio of the Total Labor Force (in %) of Spain in 2005 to that in 2010?
Give a very brief answer. 1.13. What is the ratio of the Total Labor Force (in %) of Thailand in 2005 to that in 2010?
Provide a succinct answer. 1.08. What is the ratio of the Total Labor Force (in %) of Least developed countries in 2005 to that in 2011?
Keep it short and to the point. 1.02. What is the ratio of the Total Labor Force (in %) in Estonia in 2005 to that in 2011?
Your response must be concise. 0.88. What is the ratio of the Total Labor Force (in %) of Spain in 2005 to that in 2011?
Your response must be concise. 1.18. What is the ratio of the Total Labor Force (in %) in Thailand in 2005 to that in 2011?
Provide a succinct answer. 1.08. What is the ratio of the Total Labor Force (in %) of Estonia in 2006 to that in 2007?
Give a very brief answer. 0.93. What is the ratio of the Total Labor Force (in %) in Spain in 2006 to that in 2007?
Offer a terse response. 1.01. What is the ratio of the Total Labor Force (in %) in Thailand in 2006 to that in 2007?
Provide a short and direct response. 0.99. What is the ratio of the Total Labor Force (in %) of Least developed countries in 2006 to that in 2008?
Your answer should be very brief. 1.01. What is the ratio of the Total Labor Force (in %) of Estonia in 2006 to that in 2008?
Offer a very short reply. 0.86. What is the ratio of the Total Labor Force (in %) of Least developed countries in 2006 to that in 2009?
Make the answer very short. 1.01. What is the ratio of the Total Labor Force (in %) in Estonia in 2006 to that in 2009?
Ensure brevity in your answer.  0.9. What is the ratio of the Total Labor Force (in %) of Spain in 2006 to that in 2009?
Offer a terse response. 1.07. What is the ratio of the Total Labor Force (in %) of Least developed countries in 2006 to that in 2010?
Your answer should be very brief. 1.01. What is the ratio of the Total Labor Force (in %) in Estonia in 2006 to that in 2010?
Provide a short and direct response. 0.95. What is the ratio of the Total Labor Force (in %) in Spain in 2006 to that in 2010?
Provide a succinct answer. 1.14. What is the ratio of the Total Labor Force (in %) in Thailand in 2006 to that in 2010?
Keep it short and to the point. 1.02. What is the ratio of the Total Labor Force (in %) of Least developed countries in 2006 to that in 2011?
Your response must be concise. 1.01. What is the ratio of the Total Labor Force (in %) of Estonia in 2006 to that in 2011?
Offer a terse response. 0.92. What is the ratio of the Total Labor Force (in %) in Spain in 2006 to that in 2011?
Keep it short and to the point. 1.19. What is the ratio of the Total Labor Force (in %) of Least developed countries in 2007 to that in 2008?
Keep it short and to the point. 1. What is the ratio of the Total Labor Force (in %) of Estonia in 2007 to that in 2008?
Provide a short and direct response. 0.92. What is the ratio of the Total Labor Force (in %) in Thailand in 2007 to that in 2008?
Give a very brief answer. 1.01. What is the ratio of the Total Labor Force (in %) of Least developed countries in 2007 to that in 2009?
Provide a succinct answer. 1.01. What is the ratio of the Total Labor Force (in %) of Estonia in 2007 to that in 2009?
Keep it short and to the point. 0.97. What is the ratio of the Total Labor Force (in %) in Spain in 2007 to that in 2009?
Your response must be concise. 1.07. What is the ratio of the Total Labor Force (in %) of Thailand in 2007 to that in 2009?
Ensure brevity in your answer.  1.01. What is the ratio of the Total Labor Force (in %) in Least developed countries in 2007 to that in 2010?
Offer a very short reply. 1.01. What is the ratio of the Total Labor Force (in %) in Estonia in 2007 to that in 2010?
Provide a succinct answer. 1.02. What is the ratio of the Total Labor Force (in %) of Spain in 2007 to that in 2010?
Your answer should be compact. 1.13. What is the ratio of the Total Labor Force (in %) in Thailand in 2007 to that in 2010?
Keep it short and to the point. 1.04. What is the ratio of the Total Labor Force (in %) of Least developed countries in 2007 to that in 2011?
Your answer should be compact. 1.01. What is the ratio of the Total Labor Force (in %) in Spain in 2007 to that in 2011?
Offer a very short reply. 1.19. What is the ratio of the Total Labor Force (in %) of Thailand in 2007 to that in 2011?
Provide a succinct answer. 1.04. What is the ratio of the Total Labor Force (in %) of Estonia in 2008 to that in 2009?
Offer a very short reply. 1.04. What is the ratio of the Total Labor Force (in %) in Spain in 2008 to that in 2009?
Your answer should be very brief. 1.06. What is the ratio of the Total Labor Force (in %) in Estonia in 2008 to that in 2010?
Ensure brevity in your answer.  1.1. What is the ratio of the Total Labor Force (in %) in Spain in 2008 to that in 2010?
Provide a short and direct response. 1.13. What is the ratio of the Total Labor Force (in %) of Thailand in 2008 to that in 2010?
Give a very brief answer. 1.03. What is the ratio of the Total Labor Force (in %) of Estonia in 2008 to that in 2011?
Keep it short and to the point. 1.07. What is the ratio of the Total Labor Force (in %) in Spain in 2008 to that in 2011?
Give a very brief answer. 1.18. What is the ratio of the Total Labor Force (in %) in Thailand in 2008 to that in 2011?
Your response must be concise. 1.03. What is the ratio of the Total Labor Force (in %) of Estonia in 2009 to that in 2010?
Offer a very short reply. 1.06. What is the ratio of the Total Labor Force (in %) in Spain in 2009 to that in 2010?
Make the answer very short. 1.06. What is the ratio of the Total Labor Force (in %) in Thailand in 2009 to that in 2010?
Give a very brief answer. 1.02. What is the ratio of the Total Labor Force (in %) in Estonia in 2009 to that in 2011?
Keep it short and to the point. 1.02. What is the ratio of the Total Labor Force (in %) in Spain in 2009 to that in 2011?
Ensure brevity in your answer.  1.11. What is the ratio of the Total Labor Force (in %) in Thailand in 2009 to that in 2011?
Your answer should be compact. 1.02. What is the ratio of the Total Labor Force (in %) in Least developed countries in 2010 to that in 2011?
Your answer should be compact. 1. What is the ratio of the Total Labor Force (in %) in Estonia in 2010 to that in 2011?
Offer a terse response. 0.96. What is the ratio of the Total Labor Force (in %) of Spain in 2010 to that in 2011?
Offer a terse response. 1.05. What is the difference between the highest and the second highest Total Labor Force (in %) of Least developed countries?
Provide a short and direct response. 0.15. What is the difference between the highest and the second highest Total Labor Force (in %) of Estonia?
Make the answer very short. 1.8. What is the difference between the highest and the second highest Total Labor Force (in %) of Spain?
Provide a short and direct response. 0.3. What is the difference between the highest and the lowest Total Labor Force (in %) in Least developed countries?
Give a very brief answer. 1.19. What is the difference between the highest and the lowest Total Labor Force (in %) in Estonia?
Keep it short and to the point. 7.3. What is the difference between the highest and the lowest Total Labor Force (in %) of Thailand?
Keep it short and to the point. 4.1. 